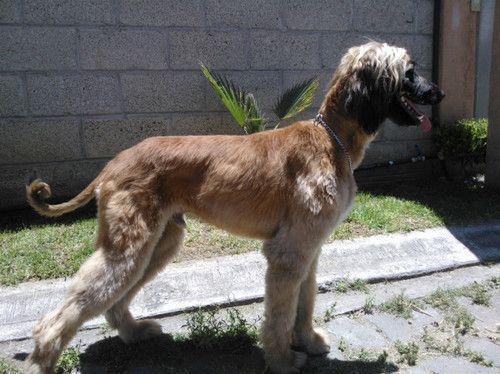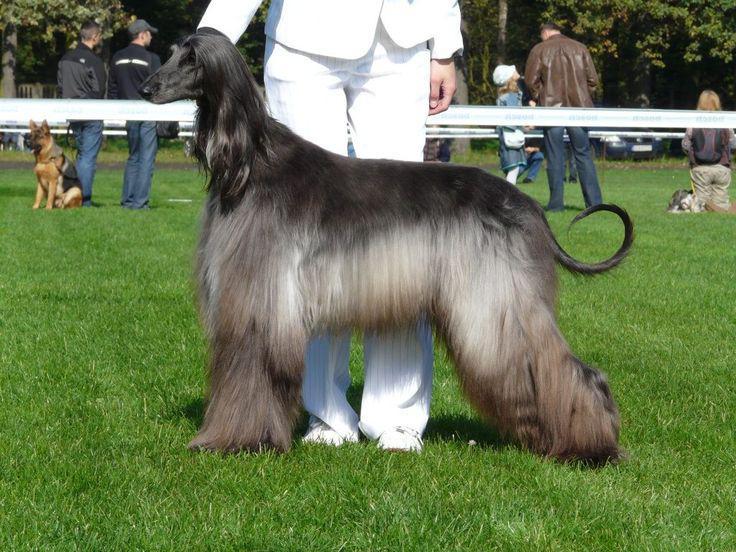The first image is the image on the left, the second image is the image on the right. Examine the images to the left and right. Is the description "A woman is on the left of an image, next to a dark afghan hound that stands in profile facing leftward." accurate? Answer yes or no. No. The first image is the image on the left, the second image is the image on the right. Considering the images on both sides, is "The dog in the image in the right is standing on in the grass with a person." valid? Answer yes or no. Yes. 